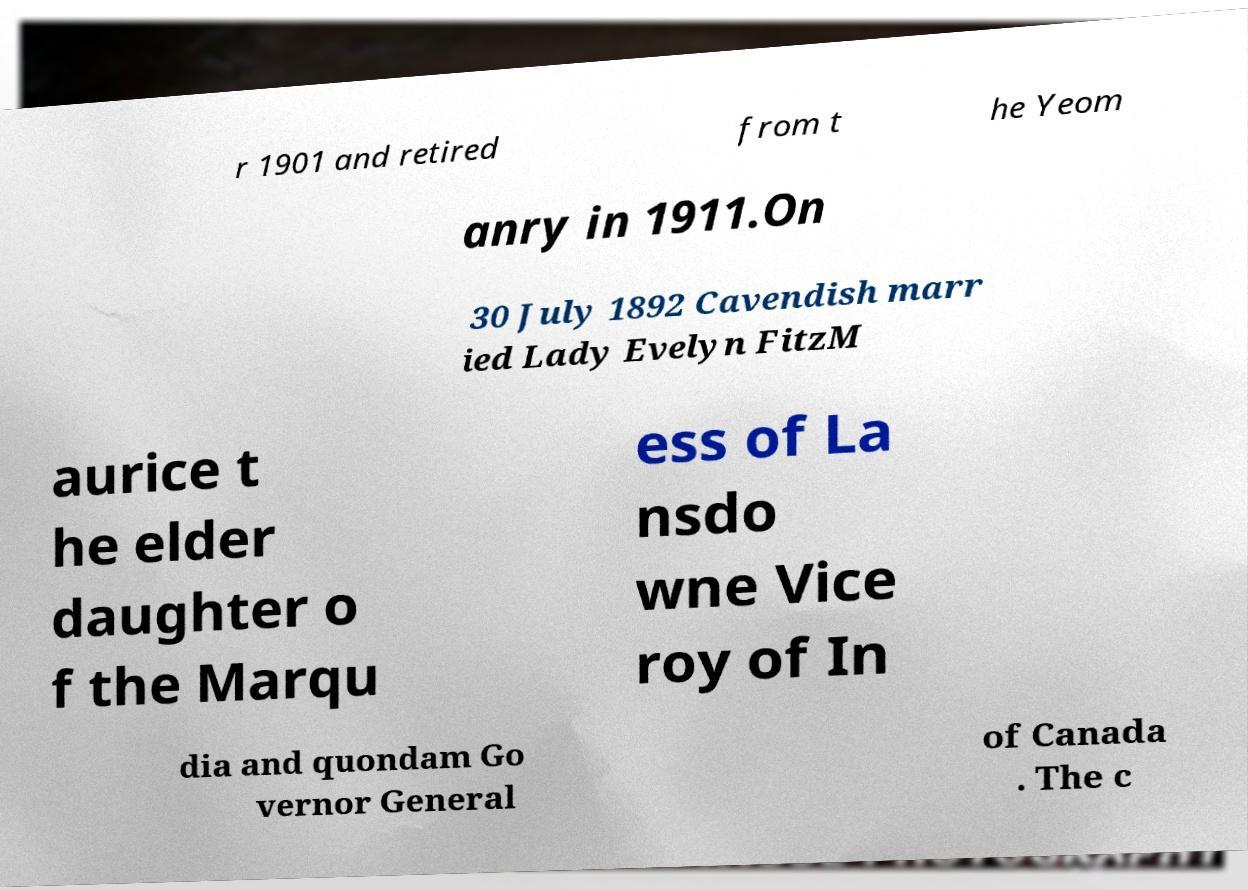There's text embedded in this image that I need extracted. Can you transcribe it verbatim? r 1901 and retired from t he Yeom anry in 1911.On 30 July 1892 Cavendish marr ied Lady Evelyn FitzM aurice t he elder daughter o f the Marqu ess of La nsdo wne Vice roy of In dia and quondam Go vernor General of Canada . The c 